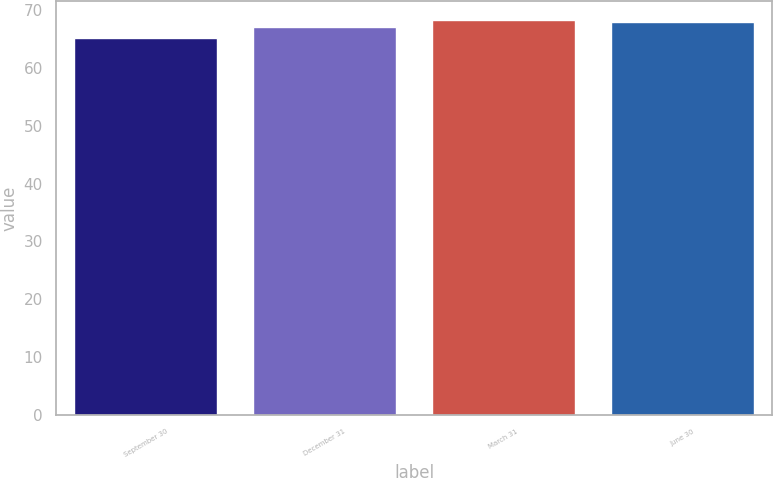Convert chart. <chart><loc_0><loc_0><loc_500><loc_500><bar_chart><fcel>September 30<fcel>December 31<fcel>March 31<fcel>June 30<nl><fcel>65.14<fcel>66.98<fcel>68.2<fcel>67.92<nl></chart> 